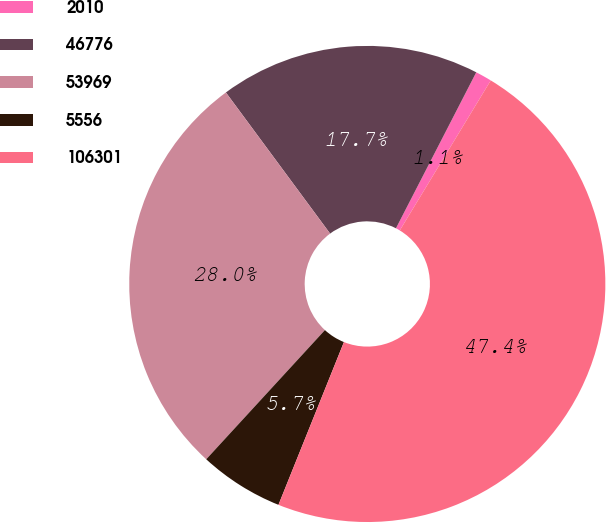<chart> <loc_0><loc_0><loc_500><loc_500><pie_chart><fcel>2010<fcel>46776<fcel>53969<fcel>5556<fcel>106301<nl><fcel>1.11%<fcel>17.69%<fcel>28.05%<fcel>5.74%<fcel>47.41%<nl></chart> 